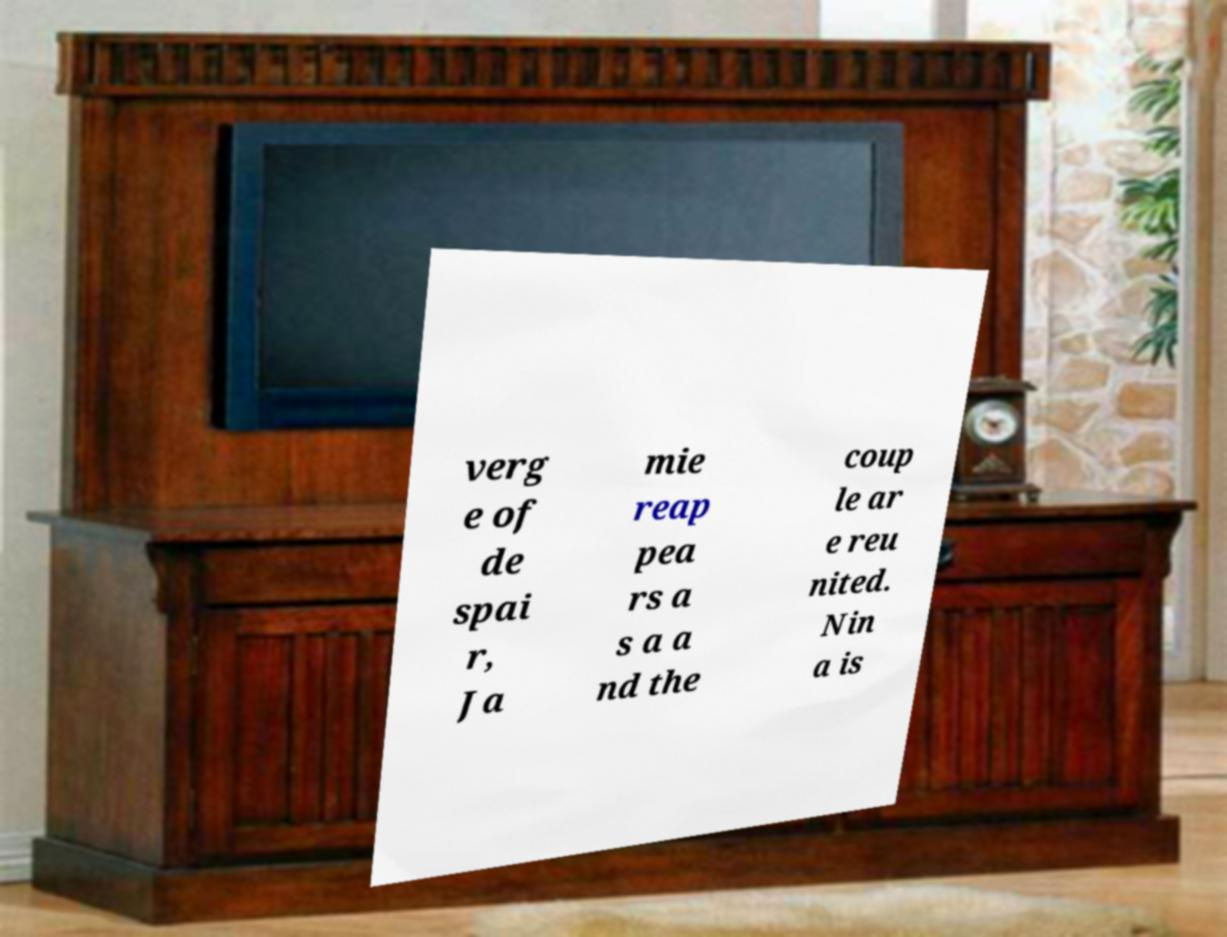Please read and relay the text visible in this image. What does it say? verg e of de spai r, Ja mie reap pea rs a s a a nd the coup le ar e reu nited. Nin a is 